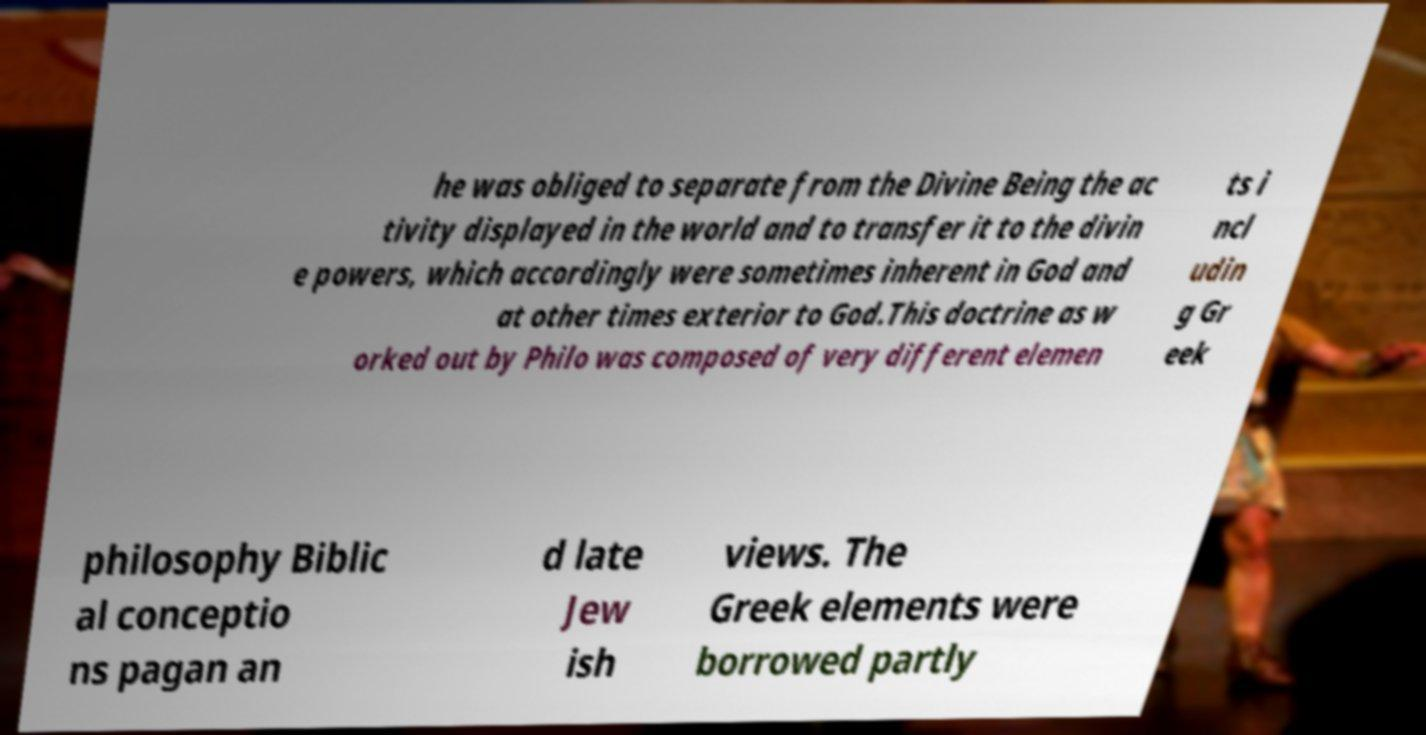Please read and relay the text visible in this image. What does it say? he was obliged to separate from the Divine Being the ac tivity displayed in the world and to transfer it to the divin e powers, which accordingly were sometimes inherent in God and at other times exterior to God.This doctrine as w orked out by Philo was composed of very different elemen ts i ncl udin g Gr eek philosophy Biblic al conceptio ns pagan an d late Jew ish views. The Greek elements were borrowed partly 